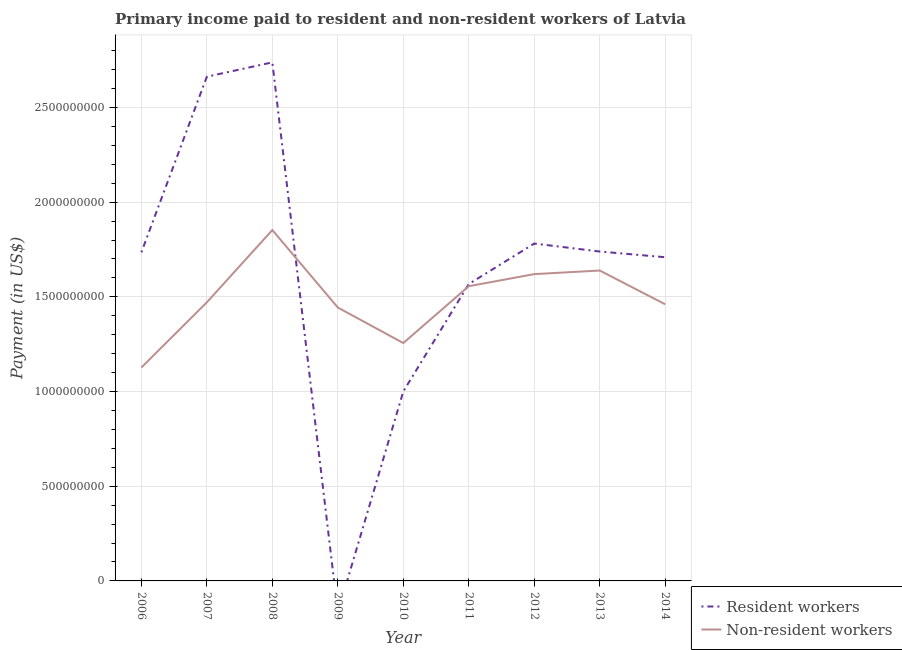How many different coloured lines are there?
Your response must be concise. 2. Does the line corresponding to payment made to non-resident workers intersect with the line corresponding to payment made to resident workers?
Offer a very short reply. Yes. Is the number of lines equal to the number of legend labels?
Your answer should be compact. No. What is the payment made to non-resident workers in 2008?
Offer a very short reply. 1.85e+09. Across all years, what is the maximum payment made to resident workers?
Provide a succinct answer. 2.74e+09. Across all years, what is the minimum payment made to non-resident workers?
Your answer should be compact. 1.13e+09. In which year was the payment made to non-resident workers maximum?
Your answer should be compact. 2008. What is the total payment made to resident workers in the graph?
Your answer should be compact. 1.49e+1. What is the difference between the payment made to resident workers in 2008 and that in 2011?
Your response must be concise. 1.17e+09. What is the difference between the payment made to resident workers in 2014 and the payment made to non-resident workers in 2010?
Give a very brief answer. 4.53e+08. What is the average payment made to resident workers per year?
Provide a short and direct response. 1.66e+09. In the year 2007, what is the difference between the payment made to resident workers and payment made to non-resident workers?
Ensure brevity in your answer.  1.19e+09. What is the ratio of the payment made to non-resident workers in 2010 to that in 2014?
Offer a very short reply. 0.86. Is the difference between the payment made to resident workers in 2010 and 2014 greater than the difference between the payment made to non-resident workers in 2010 and 2014?
Provide a succinct answer. No. What is the difference between the highest and the second highest payment made to non-resident workers?
Keep it short and to the point. 2.14e+08. What is the difference between the highest and the lowest payment made to resident workers?
Your response must be concise. 2.74e+09. In how many years, is the payment made to non-resident workers greater than the average payment made to non-resident workers taken over all years?
Offer a very short reply. 4. Is the sum of the payment made to non-resident workers in 2009 and 2014 greater than the maximum payment made to resident workers across all years?
Keep it short and to the point. Yes. Does the payment made to non-resident workers monotonically increase over the years?
Keep it short and to the point. No. Is the payment made to resident workers strictly greater than the payment made to non-resident workers over the years?
Your response must be concise. No. Is the payment made to non-resident workers strictly less than the payment made to resident workers over the years?
Provide a succinct answer. No. How many lines are there?
Keep it short and to the point. 2. What is the difference between two consecutive major ticks on the Y-axis?
Ensure brevity in your answer.  5.00e+08. Does the graph contain any zero values?
Provide a short and direct response. Yes. Where does the legend appear in the graph?
Ensure brevity in your answer.  Bottom right. How many legend labels are there?
Your answer should be compact. 2. How are the legend labels stacked?
Your answer should be very brief. Vertical. What is the title of the graph?
Keep it short and to the point. Primary income paid to resident and non-resident workers of Latvia. Does "Under-5(female)" appear as one of the legend labels in the graph?
Your response must be concise. No. What is the label or title of the X-axis?
Keep it short and to the point. Year. What is the label or title of the Y-axis?
Offer a terse response. Payment (in US$). What is the Payment (in US$) of Resident workers in 2006?
Your answer should be compact. 1.74e+09. What is the Payment (in US$) of Non-resident workers in 2006?
Your answer should be compact. 1.13e+09. What is the Payment (in US$) of Resident workers in 2007?
Provide a succinct answer. 2.66e+09. What is the Payment (in US$) of Non-resident workers in 2007?
Keep it short and to the point. 1.47e+09. What is the Payment (in US$) of Resident workers in 2008?
Ensure brevity in your answer.  2.74e+09. What is the Payment (in US$) in Non-resident workers in 2008?
Offer a very short reply. 1.85e+09. What is the Payment (in US$) of Resident workers in 2009?
Offer a terse response. 0. What is the Payment (in US$) of Non-resident workers in 2009?
Your response must be concise. 1.44e+09. What is the Payment (in US$) in Resident workers in 2010?
Offer a terse response. 1.00e+09. What is the Payment (in US$) in Non-resident workers in 2010?
Provide a succinct answer. 1.26e+09. What is the Payment (in US$) of Resident workers in 2011?
Your answer should be very brief. 1.57e+09. What is the Payment (in US$) of Non-resident workers in 2011?
Provide a short and direct response. 1.56e+09. What is the Payment (in US$) of Resident workers in 2012?
Ensure brevity in your answer.  1.78e+09. What is the Payment (in US$) in Non-resident workers in 2012?
Offer a terse response. 1.62e+09. What is the Payment (in US$) in Resident workers in 2013?
Provide a succinct answer. 1.74e+09. What is the Payment (in US$) in Non-resident workers in 2013?
Keep it short and to the point. 1.64e+09. What is the Payment (in US$) in Resident workers in 2014?
Offer a terse response. 1.71e+09. What is the Payment (in US$) in Non-resident workers in 2014?
Your response must be concise. 1.46e+09. Across all years, what is the maximum Payment (in US$) of Resident workers?
Ensure brevity in your answer.  2.74e+09. Across all years, what is the maximum Payment (in US$) in Non-resident workers?
Provide a short and direct response. 1.85e+09. Across all years, what is the minimum Payment (in US$) in Non-resident workers?
Keep it short and to the point. 1.13e+09. What is the total Payment (in US$) in Resident workers in the graph?
Make the answer very short. 1.49e+1. What is the total Payment (in US$) in Non-resident workers in the graph?
Provide a short and direct response. 1.34e+1. What is the difference between the Payment (in US$) in Resident workers in 2006 and that in 2007?
Make the answer very short. -9.28e+08. What is the difference between the Payment (in US$) in Non-resident workers in 2006 and that in 2007?
Your answer should be very brief. -3.44e+08. What is the difference between the Payment (in US$) of Resident workers in 2006 and that in 2008?
Your answer should be compact. -1.00e+09. What is the difference between the Payment (in US$) in Non-resident workers in 2006 and that in 2008?
Offer a very short reply. -7.26e+08. What is the difference between the Payment (in US$) of Non-resident workers in 2006 and that in 2009?
Provide a short and direct response. -3.17e+08. What is the difference between the Payment (in US$) of Resident workers in 2006 and that in 2010?
Provide a succinct answer. 7.35e+08. What is the difference between the Payment (in US$) of Non-resident workers in 2006 and that in 2010?
Your response must be concise. -1.29e+08. What is the difference between the Payment (in US$) in Resident workers in 2006 and that in 2011?
Offer a terse response. 1.67e+08. What is the difference between the Payment (in US$) in Non-resident workers in 2006 and that in 2011?
Offer a very short reply. -4.29e+08. What is the difference between the Payment (in US$) in Resident workers in 2006 and that in 2012?
Make the answer very short. -4.64e+07. What is the difference between the Payment (in US$) of Non-resident workers in 2006 and that in 2012?
Your answer should be compact. -4.93e+08. What is the difference between the Payment (in US$) of Resident workers in 2006 and that in 2013?
Make the answer very short. -4.31e+06. What is the difference between the Payment (in US$) of Non-resident workers in 2006 and that in 2013?
Offer a very short reply. -5.12e+08. What is the difference between the Payment (in US$) in Resident workers in 2006 and that in 2014?
Provide a short and direct response. 2.58e+07. What is the difference between the Payment (in US$) of Non-resident workers in 2006 and that in 2014?
Provide a short and direct response. -3.34e+08. What is the difference between the Payment (in US$) of Resident workers in 2007 and that in 2008?
Provide a succinct answer. -7.55e+07. What is the difference between the Payment (in US$) of Non-resident workers in 2007 and that in 2008?
Keep it short and to the point. -3.82e+08. What is the difference between the Payment (in US$) of Non-resident workers in 2007 and that in 2009?
Your response must be concise. 2.75e+07. What is the difference between the Payment (in US$) in Resident workers in 2007 and that in 2010?
Your answer should be very brief. 1.66e+09. What is the difference between the Payment (in US$) of Non-resident workers in 2007 and that in 2010?
Provide a succinct answer. 2.15e+08. What is the difference between the Payment (in US$) of Resident workers in 2007 and that in 2011?
Your answer should be compact. 1.09e+09. What is the difference between the Payment (in US$) in Non-resident workers in 2007 and that in 2011?
Offer a terse response. -8.51e+07. What is the difference between the Payment (in US$) of Resident workers in 2007 and that in 2012?
Give a very brief answer. 8.81e+08. What is the difference between the Payment (in US$) of Non-resident workers in 2007 and that in 2012?
Provide a short and direct response. -1.49e+08. What is the difference between the Payment (in US$) of Resident workers in 2007 and that in 2013?
Offer a very short reply. 9.23e+08. What is the difference between the Payment (in US$) of Non-resident workers in 2007 and that in 2013?
Your answer should be very brief. -1.68e+08. What is the difference between the Payment (in US$) of Resident workers in 2007 and that in 2014?
Provide a short and direct response. 9.53e+08. What is the difference between the Payment (in US$) of Non-resident workers in 2007 and that in 2014?
Offer a very short reply. 1.06e+07. What is the difference between the Payment (in US$) of Non-resident workers in 2008 and that in 2009?
Your response must be concise. 4.09e+08. What is the difference between the Payment (in US$) of Resident workers in 2008 and that in 2010?
Give a very brief answer. 1.74e+09. What is the difference between the Payment (in US$) of Non-resident workers in 2008 and that in 2010?
Give a very brief answer. 5.97e+08. What is the difference between the Payment (in US$) in Resident workers in 2008 and that in 2011?
Ensure brevity in your answer.  1.17e+09. What is the difference between the Payment (in US$) in Non-resident workers in 2008 and that in 2011?
Your answer should be compact. 2.97e+08. What is the difference between the Payment (in US$) of Resident workers in 2008 and that in 2012?
Offer a terse response. 9.57e+08. What is the difference between the Payment (in US$) of Non-resident workers in 2008 and that in 2012?
Your answer should be compact. 2.33e+08. What is the difference between the Payment (in US$) of Resident workers in 2008 and that in 2013?
Offer a very short reply. 9.99e+08. What is the difference between the Payment (in US$) of Non-resident workers in 2008 and that in 2013?
Ensure brevity in your answer.  2.14e+08. What is the difference between the Payment (in US$) in Resident workers in 2008 and that in 2014?
Your answer should be very brief. 1.03e+09. What is the difference between the Payment (in US$) of Non-resident workers in 2008 and that in 2014?
Offer a very short reply. 3.92e+08. What is the difference between the Payment (in US$) of Non-resident workers in 2009 and that in 2010?
Your response must be concise. 1.88e+08. What is the difference between the Payment (in US$) in Non-resident workers in 2009 and that in 2011?
Provide a short and direct response. -1.13e+08. What is the difference between the Payment (in US$) of Non-resident workers in 2009 and that in 2012?
Make the answer very short. -1.76e+08. What is the difference between the Payment (in US$) of Non-resident workers in 2009 and that in 2013?
Give a very brief answer. -1.95e+08. What is the difference between the Payment (in US$) in Non-resident workers in 2009 and that in 2014?
Provide a short and direct response. -1.69e+07. What is the difference between the Payment (in US$) in Resident workers in 2010 and that in 2011?
Your response must be concise. -5.67e+08. What is the difference between the Payment (in US$) in Non-resident workers in 2010 and that in 2011?
Your answer should be very brief. -3.00e+08. What is the difference between the Payment (in US$) in Resident workers in 2010 and that in 2012?
Provide a short and direct response. -7.81e+08. What is the difference between the Payment (in US$) of Non-resident workers in 2010 and that in 2012?
Provide a succinct answer. -3.64e+08. What is the difference between the Payment (in US$) in Resident workers in 2010 and that in 2013?
Your answer should be very brief. -7.39e+08. What is the difference between the Payment (in US$) of Non-resident workers in 2010 and that in 2013?
Keep it short and to the point. -3.83e+08. What is the difference between the Payment (in US$) of Resident workers in 2010 and that in 2014?
Give a very brief answer. -7.09e+08. What is the difference between the Payment (in US$) of Non-resident workers in 2010 and that in 2014?
Your answer should be very brief. -2.04e+08. What is the difference between the Payment (in US$) in Resident workers in 2011 and that in 2012?
Make the answer very short. -2.14e+08. What is the difference between the Payment (in US$) in Non-resident workers in 2011 and that in 2012?
Give a very brief answer. -6.37e+07. What is the difference between the Payment (in US$) in Resident workers in 2011 and that in 2013?
Offer a terse response. -1.72e+08. What is the difference between the Payment (in US$) of Non-resident workers in 2011 and that in 2013?
Provide a short and direct response. -8.27e+07. What is the difference between the Payment (in US$) in Resident workers in 2011 and that in 2014?
Provide a succinct answer. -1.42e+08. What is the difference between the Payment (in US$) in Non-resident workers in 2011 and that in 2014?
Give a very brief answer. 9.57e+07. What is the difference between the Payment (in US$) in Resident workers in 2012 and that in 2013?
Make the answer very short. 4.21e+07. What is the difference between the Payment (in US$) of Non-resident workers in 2012 and that in 2013?
Give a very brief answer. -1.90e+07. What is the difference between the Payment (in US$) in Resident workers in 2012 and that in 2014?
Your answer should be very brief. 7.22e+07. What is the difference between the Payment (in US$) of Non-resident workers in 2012 and that in 2014?
Keep it short and to the point. 1.59e+08. What is the difference between the Payment (in US$) of Resident workers in 2013 and that in 2014?
Make the answer very short. 3.01e+07. What is the difference between the Payment (in US$) in Non-resident workers in 2013 and that in 2014?
Make the answer very short. 1.78e+08. What is the difference between the Payment (in US$) of Resident workers in 2006 and the Payment (in US$) of Non-resident workers in 2007?
Your answer should be compact. 2.64e+08. What is the difference between the Payment (in US$) in Resident workers in 2006 and the Payment (in US$) in Non-resident workers in 2008?
Your answer should be compact. -1.18e+08. What is the difference between the Payment (in US$) of Resident workers in 2006 and the Payment (in US$) of Non-resident workers in 2009?
Provide a succinct answer. 2.91e+08. What is the difference between the Payment (in US$) of Resident workers in 2006 and the Payment (in US$) of Non-resident workers in 2010?
Ensure brevity in your answer.  4.79e+08. What is the difference between the Payment (in US$) in Resident workers in 2006 and the Payment (in US$) in Non-resident workers in 2011?
Your answer should be compact. 1.79e+08. What is the difference between the Payment (in US$) of Resident workers in 2006 and the Payment (in US$) of Non-resident workers in 2012?
Offer a terse response. 1.15e+08. What is the difference between the Payment (in US$) in Resident workers in 2006 and the Payment (in US$) in Non-resident workers in 2013?
Provide a succinct answer. 9.60e+07. What is the difference between the Payment (in US$) of Resident workers in 2006 and the Payment (in US$) of Non-resident workers in 2014?
Your answer should be compact. 2.74e+08. What is the difference between the Payment (in US$) of Resident workers in 2007 and the Payment (in US$) of Non-resident workers in 2008?
Keep it short and to the point. 8.10e+08. What is the difference between the Payment (in US$) of Resident workers in 2007 and the Payment (in US$) of Non-resident workers in 2009?
Your response must be concise. 1.22e+09. What is the difference between the Payment (in US$) in Resident workers in 2007 and the Payment (in US$) in Non-resident workers in 2010?
Provide a short and direct response. 1.41e+09. What is the difference between the Payment (in US$) of Resident workers in 2007 and the Payment (in US$) of Non-resident workers in 2011?
Provide a short and direct response. 1.11e+09. What is the difference between the Payment (in US$) of Resident workers in 2007 and the Payment (in US$) of Non-resident workers in 2012?
Provide a short and direct response. 1.04e+09. What is the difference between the Payment (in US$) in Resident workers in 2007 and the Payment (in US$) in Non-resident workers in 2013?
Give a very brief answer. 1.02e+09. What is the difference between the Payment (in US$) of Resident workers in 2007 and the Payment (in US$) of Non-resident workers in 2014?
Offer a terse response. 1.20e+09. What is the difference between the Payment (in US$) of Resident workers in 2008 and the Payment (in US$) of Non-resident workers in 2009?
Provide a short and direct response. 1.29e+09. What is the difference between the Payment (in US$) in Resident workers in 2008 and the Payment (in US$) in Non-resident workers in 2010?
Offer a very short reply. 1.48e+09. What is the difference between the Payment (in US$) of Resident workers in 2008 and the Payment (in US$) of Non-resident workers in 2011?
Keep it short and to the point. 1.18e+09. What is the difference between the Payment (in US$) in Resident workers in 2008 and the Payment (in US$) in Non-resident workers in 2012?
Your answer should be very brief. 1.12e+09. What is the difference between the Payment (in US$) of Resident workers in 2008 and the Payment (in US$) of Non-resident workers in 2013?
Your response must be concise. 1.10e+09. What is the difference between the Payment (in US$) in Resident workers in 2008 and the Payment (in US$) in Non-resident workers in 2014?
Provide a succinct answer. 1.28e+09. What is the difference between the Payment (in US$) of Resident workers in 2010 and the Payment (in US$) of Non-resident workers in 2011?
Your answer should be compact. -5.56e+08. What is the difference between the Payment (in US$) of Resident workers in 2010 and the Payment (in US$) of Non-resident workers in 2012?
Ensure brevity in your answer.  -6.20e+08. What is the difference between the Payment (in US$) in Resident workers in 2010 and the Payment (in US$) in Non-resident workers in 2013?
Offer a terse response. -6.39e+08. What is the difference between the Payment (in US$) of Resident workers in 2010 and the Payment (in US$) of Non-resident workers in 2014?
Provide a succinct answer. -4.60e+08. What is the difference between the Payment (in US$) in Resident workers in 2011 and the Payment (in US$) in Non-resident workers in 2012?
Your answer should be compact. -5.23e+07. What is the difference between the Payment (in US$) in Resident workers in 2011 and the Payment (in US$) in Non-resident workers in 2013?
Keep it short and to the point. -7.13e+07. What is the difference between the Payment (in US$) of Resident workers in 2011 and the Payment (in US$) of Non-resident workers in 2014?
Your answer should be very brief. 1.07e+08. What is the difference between the Payment (in US$) of Resident workers in 2012 and the Payment (in US$) of Non-resident workers in 2013?
Give a very brief answer. 1.42e+08. What is the difference between the Payment (in US$) of Resident workers in 2012 and the Payment (in US$) of Non-resident workers in 2014?
Keep it short and to the point. 3.21e+08. What is the difference between the Payment (in US$) in Resident workers in 2013 and the Payment (in US$) in Non-resident workers in 2014?
Make the answer very short. 2.79e+08. What is the average Payment (in US$) in Resident workers per year?
Your answer should be compact. 1.66e+09. What is the average Payment (in US$) of Non-resident workers per year?
Offer a very short reply. 1.49e+09. In the year 2006, what is the difference between the Payment (in US$) of Resident workers and Payment (in US$) of Non-resident workers?
Ensure brevity in your answer.  6.08e+08. In the year 2007, what is the difference between the Payment (in US$) in Resident workers and Payment (in US$) in Non-resident workers?
Offer a very short reply. 1.19e+09. In the year 2008, what is the difference between the Payment (in US$) in Resident workers and Payment (in US$) in Non-resident workers?
Offer a terse response. 8.85e+08. In the year 2010, what is the difference between the Payment (in US$) of Resident workers and Payment (in US$) of Non-resident workers?
Provide a short and direct response. -2.56e+08. In the year 2011, what is the difference between the Payment (in US$) of Resident workers and Payment (in US$) of Non-resident workers?
Give a very brief answer. 1.14e+07. In the year 2012, what is the difference between the Payment (in US$) of Resident workers and Payment (in US$) of Non-resident workers?
Provide a short and direct response. 1.61e+08. In the year 2013, what is the difference between the Payment (in US$) in Resident workers and Payment (in US$) in Non-resident workers?
Keep it short and to the point. 1.00e+08. In the year 2014, what is the difference between the Payment (in US$) of Resident workers and Payment (in US$) of Non-resident workers?
Provide a short and direct response. 2.49e+08. What is the ratio of the Payment (in US$) of Resident workers in 2006 to that in 2007?
Keep it short and to the point. 0.65. What is the ratio of the Payment (in US$) in Non-resident workers in 2006 to that in 2007?
Offer a very short reply. 0.77. What is the ratio of the Payment (in US$) in Resident workers in 2006 to that in 2008?
Give a very brief answer. 0.63. What is the ratio of the Payment (in US$) of Non-resident workers in 2006 to that in 2008?
Make the answer very short. 0.61. What is the ratio of the Payment (in US$) in Non-resident workers in 2006 to that in 2009?
Your answer should be very brief. 0.78. What is the ratio of the Payment (in US$) of Resident workers in 2006 to that in 2010?
Your answer should be very brief. 1.73. What is the ratio of the Payment (in US$) of Non-resident workers in 2006 to that in 2010?
Ensure brevity in your answer.  0.9. What is the ratio of the Payment (in US$) in Resident workers in 2006 to that in 2011?
Provide a succinct answer. 1.11. What is the ratio of the Payment (in US$) in Non-resident workers in 2006 to that in 2011?
Make the answer very short. 0.72. What is the ratio of the Payment (in US$) in Resident workers in 2006 to that in 2012?
Offer a very short reply. 0.97. What is the ratio of the Payment (in US$) in Non-resident workers in 2006 to that in 2012?
Your answer should be compact. 0.7. What is the ratio of the Payment (in US$) of Resident workers in 2006 to that in 2013?
Keep it short and to the point. 1. What is the ratio of the Payment (in US$) in Non-resident workers in 2006 to that in 2013?
Your answer should be very brief. 0.69. What is the ratio of the Payment (in US$) of Resident workers in 2006 to that in 2014?
Offer a very short reply. 1.02. What is the ratio of the Payment (in US$) of Non-resident workers in 2006 to that in 2014?
Your response must be concise. 0.77. What is the ratio of the Payment (in US$) of Resident workers in 2007 to that in 2008?
Offer a very short reply. 0.97. What is the ratio of the Payment (in US$) of Non-resident workers in 2007 to that in 2008?
Offer a terse response. 0.79. What is the ratio of the Payment (in US$) in Non-resident workers in 2007 to that in 2009?
Your answer should be very brief. 1.02. What is the ratio of the Payment (in US$) in Resident workers in 2007 to that in 2010?
Make the answer very short. 2.66. What is the ratio of the Payment (in US$) in Non-resident workers in 2007 to that in 2010?
Ensure brevity in your answer.  1.17. What is the ratio of the Payment (in US$) in Resident workers in 2007 to that in 2011?
Your response must be concise. 1.7. What is the ratio of the Payment (in US$) of Non-resident workers in 2007 to that in 2011?
Ensure brevity in your answer.  0.95. What is the ratio of the Payment (in US$) of Resident workers in 2007 to that in 2012?
Your answer should be very brief. 1.49. What is the ratio of the Payment (in US$) of Non-resident workers in 2007 to that in 2012?
Provide a short and direct response. 0.91. What is the ratio of the Payment (in US$) in Resident workers in 2007 to that in 2013?
Your response must be concise. 1.53. What is the ratio of the Payment (in US$) in Non-resident workers in 2007 to that in 2013?
Your answer should be compact. 0.9. What is the ratio of the Payment (in US$) of Resident workers in 2007 to that in 2014?
Offer a very short reply. 1.56. What is the ratio of the Payment (in US$) of Non-resident workers in 2007 to that in 2014?
Offer a very short reply. 1.01. What is the ratio of the Payment (in US$) in Non-resident workers in 2008 to that in 2009?
Keep it short and to the point. 1.28. What is the ratio of the Payment (in US$) in Resident workers in 2008 to that in 2010?
Your answer should be compact. 2.74. What is the ratio of the Payment (in US$) in Non-resident workers in 2008 to that in 2010?
Offer a very short reply. 1.48. What is the ratio of the Payment (in US$) of Resident workers in 2008 to that in 2011?
Keep it short and to the point. 1.75. What is the ratio of the Payment (in US$) of Non-resident workers in 2008 to that in 2011?
Make the answer very short. 1.19. What is the ratio of the Payment (in US$) of Resident workers in 2008 to that in 2012?
Your response must be concise. 1.54. What is the ratio of the Payment (in US$) in Non-resident workers in 2008 to that in 2012?
Your response must be concise. 1.14. What is the ratio of the Payment (in US$) of Resident workers in 2008 to that in 2013?
Make the answer very short. 1.57. What is the ratio of the Payment (in US$) in Non-resident workers in 2008 to that in 2013?
Offer a terse response. 1.13. What is the ratio of the Payment (in US$) of Resident workers in 2008 to that in 2014?
Offer a very short reply. 1.6. What is the ratio of the Payment (in US$) in Non-resident workers in 2008 to that in 2014?
Your answer should be very brief. 1.27. What is the ratio of the Payment (in US$) in Non-resident workers in 2009 to that in 2010?
Provide a succinct answer. 1.15. What is the ratio of the Payment (in US$) in Non-resident workers in 2009 to that in 2011?
Ensure brevity in your answer.  0.93. What is the ratio of the Payment (in US$) of Non-resident workers in 2009 to that in 2012?
Ensure brevity in your answer.  0.89. What is the ratio of the Payment (in US$) of Non-resident workers in 2009 to that in 2013?
Make the answer very short. 0.88. What is the ratio of the Payment (in US$) in Non-resident workers in 2009 to that in 2014?
Provide a succinct answer. 0.99. What is the ratio of the Payment (in US$) of Resident workers in 2010 to that in 2011?
Offer a terse response. 0.64. What is the ratio of the Payment (in US$) in Non-resident workers in 2010 to that in 2011?
Your response must be concise. 0.81. What is the ratio of the Payment (in US$) of Resident workers in 2010 to that in 2012?
Ensure brevity in your answer.  0.56. What is the ratio of the Payment (in US$) in Non-resident workers in 2010 to that in 2012?
Your answer should be compact. 0.78. What is the ratio of the Payment (in US$) of Resident workers in 2010 to that in 2013?
Your response must be concise. 0.58. What is the ratio of the Payment (in US$) of Non-resident workers in 2010 to that in 2013?
Provide a short and direct response. 0.77. What is the ratio of the Payment (in US$) of Resident workers in 2010 to that in 2014?
Provide a succinct answer. 0.59. What is the ratio of the Payment (in US$) in Non-resident workers in 2010 to that in 2014?
Your answer should be compact. 0.86. What is the ratio of the Payment (in US$) of Non-resident workers in 2011 to that in 2012?
Make the answer very short. 0.96. What is the ratio of the Payment (in US$) of Resident workers in 2011 to that in 2013?
Give a very brief answer. 0.9. What is the ratio of the Payment (in US$) of Non-resident workers in 2011 to that in 2013?
Give a very brief answer. 0.95. What is the ratio of the Payment (in US$) of Resident workers in 2011 to that in 2014?
Keep it short and to the point. 0.92. What is the ratio of the Payment (in US$) of Non-resident workers in 2011 to that in 2014?
Offer a very short reply. 1.07. What is the ratio of the Payment (in US$) in Resident workers in 2012 to that in 2013?
Your answer should be compact. 1.02. What is the ratio of the Payment (in US$) in Non-resident workers in 2012 to that in 2013?
Give a very brief answer. 0.99. What is the ratio of the Payment (in US$) of Resident workers in 2012 to that in 2014?
Your response must be concise. 1.04. What is the ratio of the Payment (in US$) of Non-resident workers in 2012 to that in 2014?
Keep it short and to the point. 1.11. What is the ratio of the Payment (in US$) of Resident workers in 2013 to that in 2014?
Offer a terse response. 1.02. What is the ratio of the Payment (in US$) in Non-resident workers in 2013 to that in 2014?
Make the answer very short. 1.12. What is the difference between the highest and the second highest Payment (in US$) of Resident workers?
Give a very brief answer. 7.55e+07. What is the difference between the highest and the second highest Payment (in US$) in Non-resident workers?
Your answer should be compact. 2.14e+08. What is the difference between the highest and the lowest Payment (in US$) of Resident workers?
Provide a succinct answer. 2.74e+09. What is the difference between the highest and the lowest Payment (in US$) in Non-resident workers?
Provide a succinct answer. 7.26e+08. 